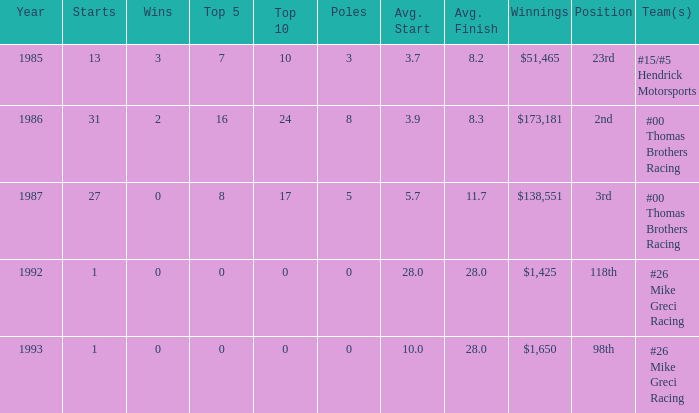What position did he finish in 1987? 3rd. 